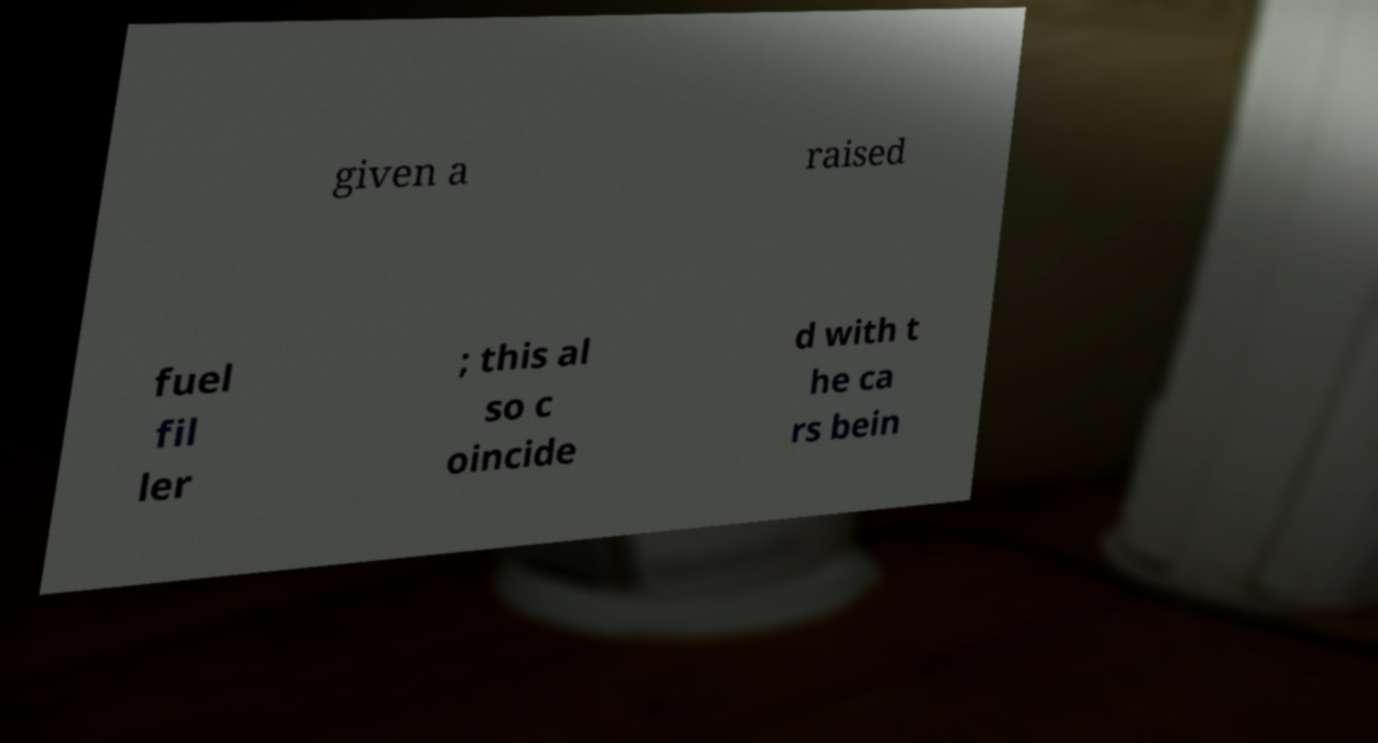Could you extract and type out the text from this image? given a raised fuel fil ler ; this al so c oincide d with t he ca rs bein 